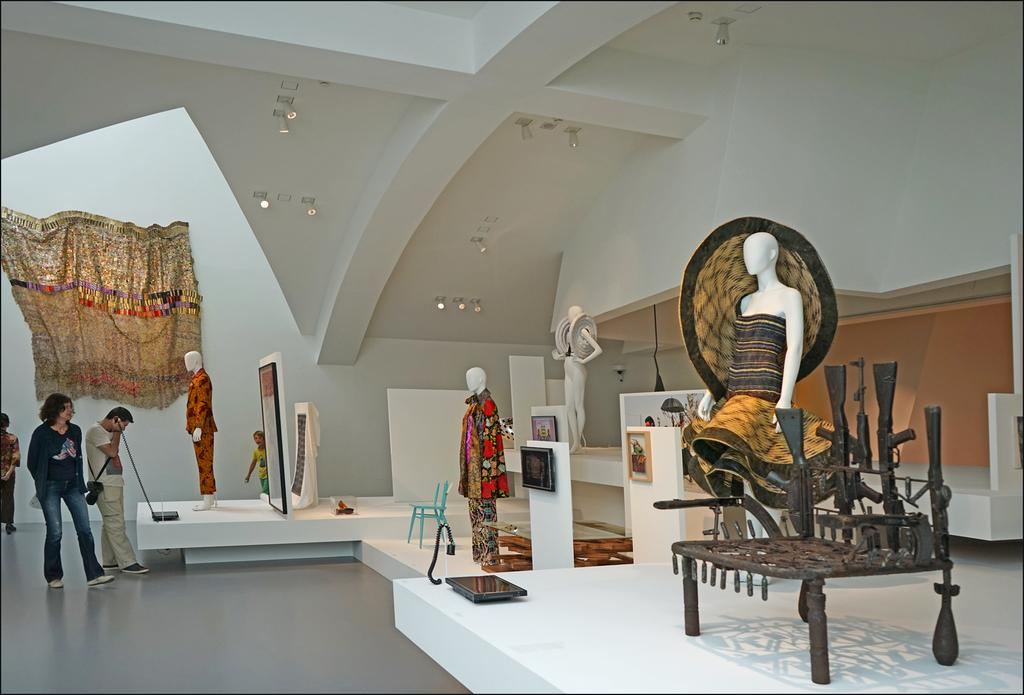What can be seen in the image? There are people standing in the image, along with statues. Can you describe the statues in the image? The statues are wearing different types of clothes. What type of throat is visible on the statues in the image? There are no throats visible on the statues in the image, as they are not living beings. 